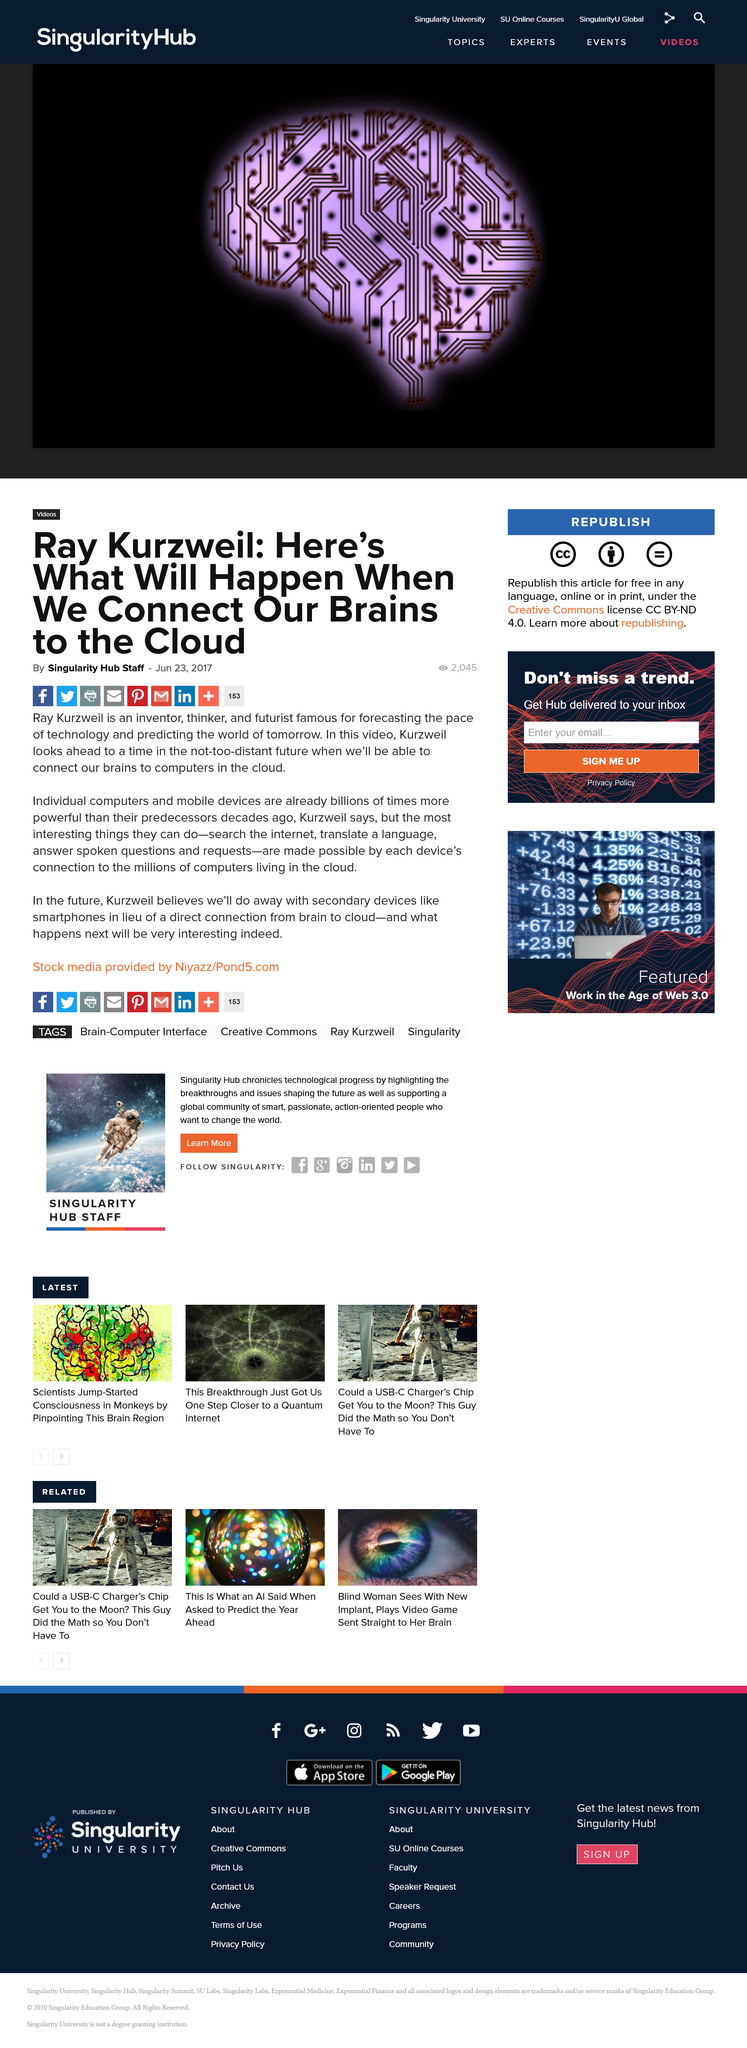Highlight a few significant elements in this photo. In this video, Kurzweil will examine the advancements in technology that will allow us to connect our brains to the cloud in the near future. With the ability to connect our brains to the cloud, we will be able to perform tasks such as searching the internet, translating languages, and answering spoken questions and requests. Ray Kurzweil is a well-known inventor, thinker, and futurist who is renowned for his predictions regarding the rapid advancement of technology and the future of our world. 